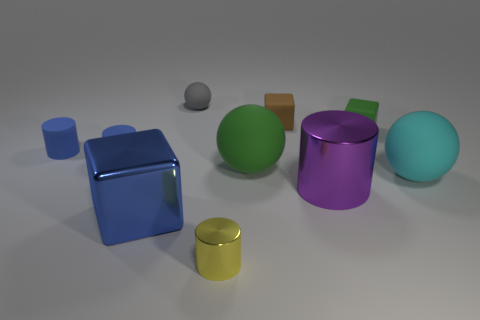Subtract all green balls. How many blue cylinders are left? 2 Subtract all purple cylinders. How many cylinders are left? 3 Subtract all cylinders. How many objects are left? 6 Subtract 3 cylinders. How many cylinders are left? 1 Subtract all purple cylinders. How many cylinders are left? 3 Add 1 large yellow rubber blocks. How many large yellow rubber blocks exist? 1 Subtract 0 gray cylinders. How many objects are left? 10 Subtract all yellow blocks. Subtract all gray cylinders. How many blocks are left? 3 Subtract all cyan matte objects. Subtract all large gray shiny objects. How many objects are left? 9 Add 5 cyan matte spheres. How many cyan matte spheres are left? 6 